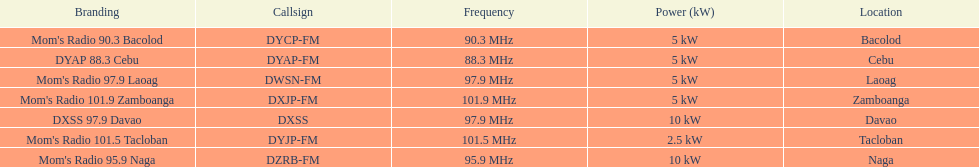How many kw was the radio in davao? 10 kW. Give me the full table as a dictionary. {'header': ['Branding', 'Callsign', 'Frequency', 'Power (kW)', 'Location'], 'rows': [["Mom's Radio 90.3 Bacolod", 'DYCP-FM', '90.3\xa0MHz', '5\xa0kW', 'Bacolod'], ['DYAP 88.3 Cebu', 'DYAP-FM', '88.3\xa0MHz', '5\xa0kW', 'Cebu'], ["Mom's Radio 97.9 Laoag", 'DWSN-FM', '97.9\xa0MHz', '5\xa0kW', 'Laoag'], ["Mom's Radio 101.9 Zamboanga", 'DXJP-FM', '101.9\xa0MHz', '5\xa0kW', 'Zamboanga'], ['DXSS 97.9 Davao', 'DXSS', '97.9\xa0MHz', '10\xa0kW', 'Davao'], ["Mom's Radio 101.5 Tacloban", 'DYJP-FM', '101.5\xa0MHz', '2.5\xa0kW', 'Tacloban'], ["Mom's Radio 95.9 Naga", 'DZRB-FM', '95.9\xa0MHz', '10\xa0kW', 'Naga']]} 